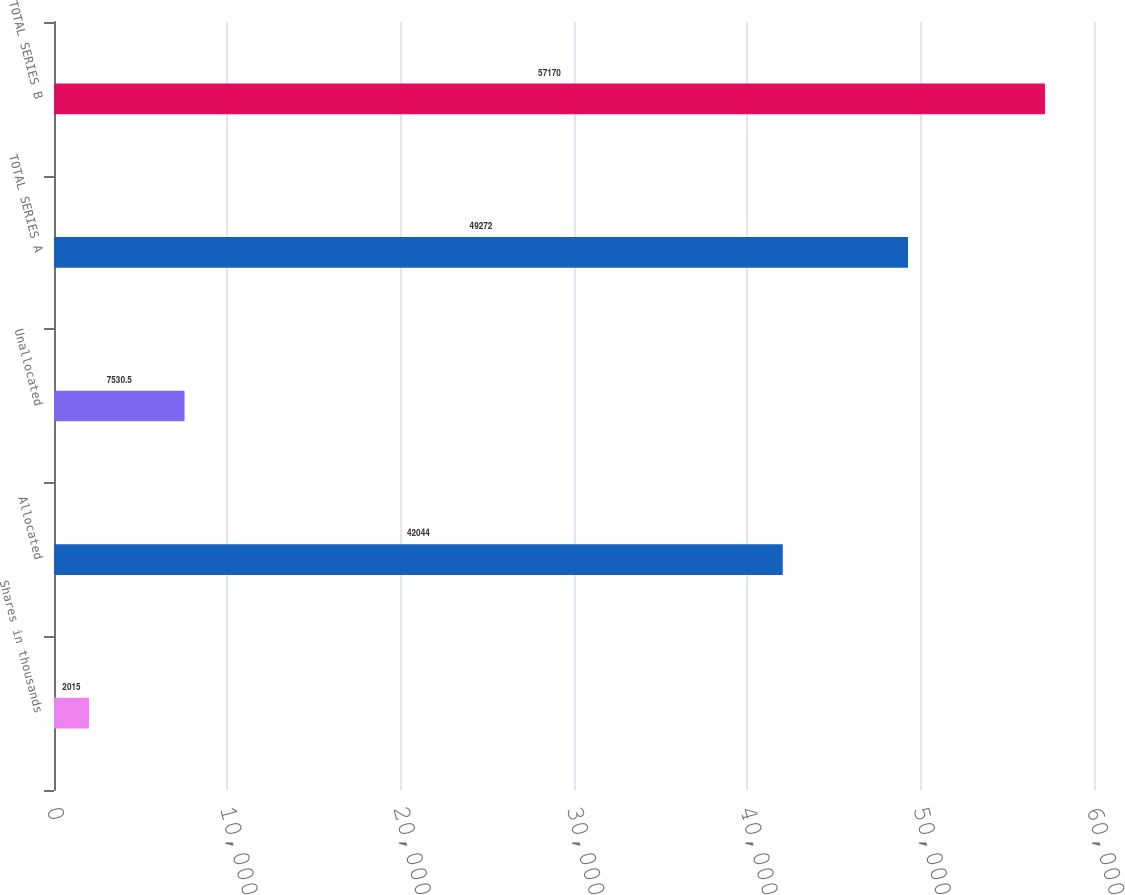Convert chart. <chart><loc_0><loc_0><loc_500><loc_500><bar_chart><fcel>Shares in thousands<fcel>Allocated<fcel>Unallocated<fcel>TOTAL SERIES A<fcel>TOTAL SERIES B<nl><fcel>2015<fcel>42044<fcel>7530.5<fcel>49272<fcel>57170<nl></chart> 